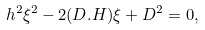Convert formula to latex. <formula><loc_0><loc_0><loc_500><loc_500>h ^ { 2 } \xi ^ { 2 } - 2 ( D . H ) \xi + D ^ { 2 } = 0 ,</formula> 